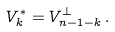Convert formula to latex. <formula><loc_0><loc_0><loc_500><loc_500>V ^ { * } _ { k } = V ^ { \perp } _ { n - 1 - k } \, .</formula> 